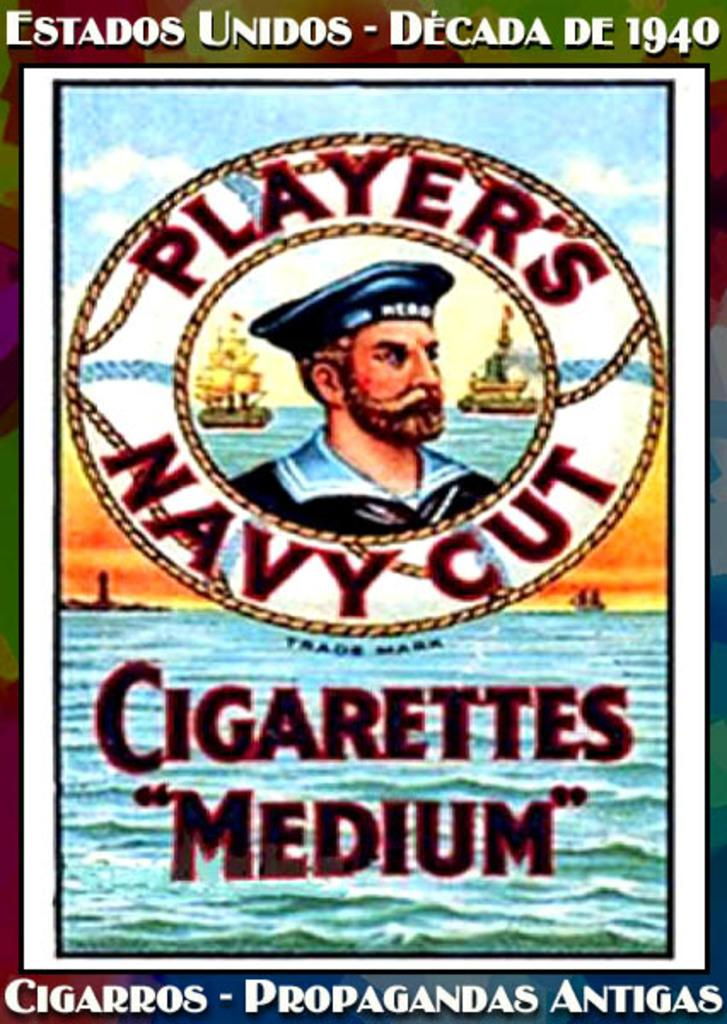<image>
Provide a brief description of the given image. a poster of Players Navy Cut Cigarettes with a man in the middle 